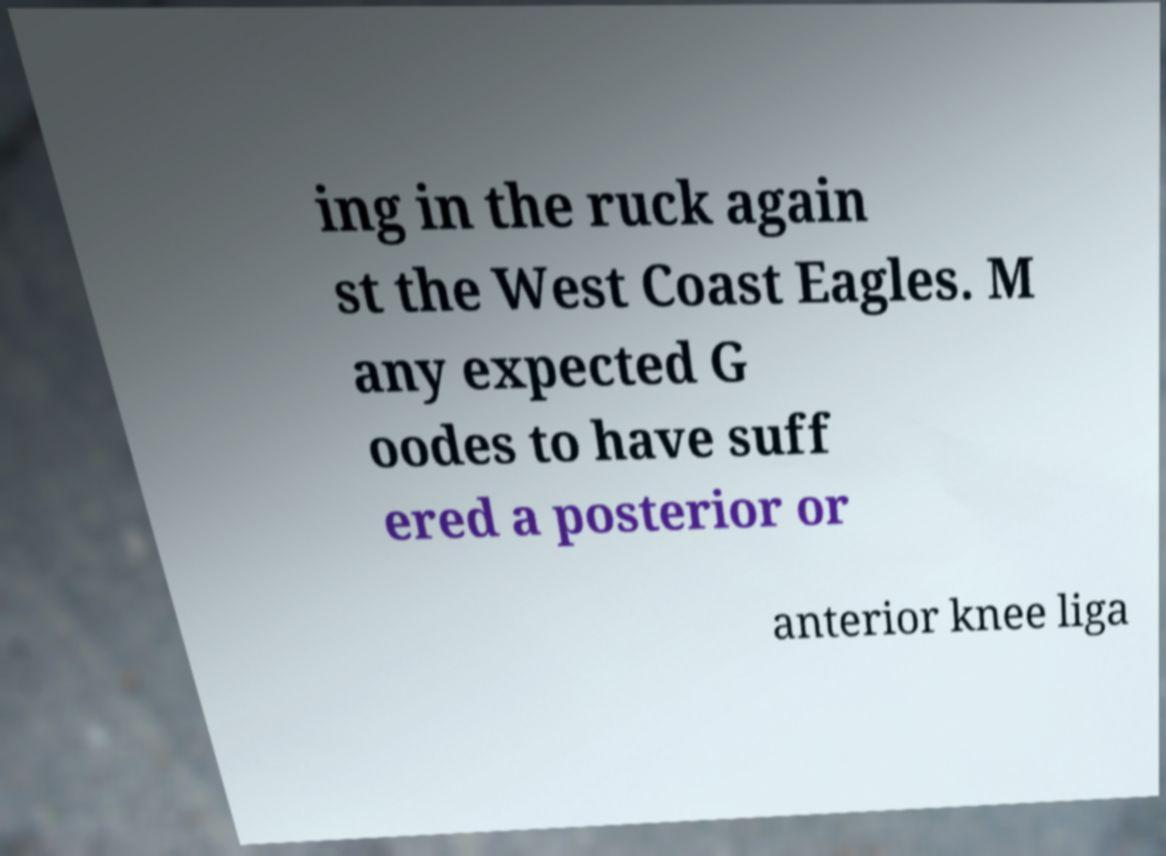Can you read and provide the text displayed in the image?This photo seems to have some interesting text. Can you extract and type it out for me? ing in the ruck again st the West Coast Eagles. M any expected G oodes to have suff ered a posterior or anterior knee liga 